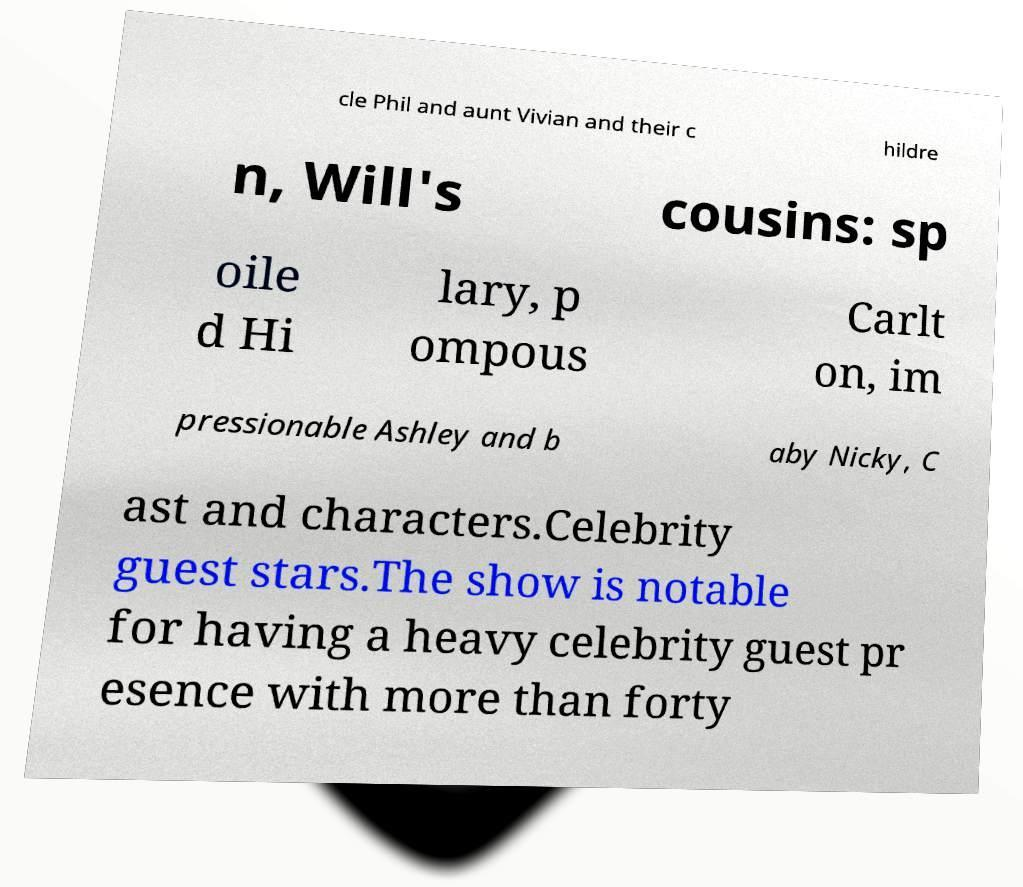I need the written content from this picture converted into text. Can you do that? cle Phil and aunt Vivian and their c hildre n, Will's cousins: sp oile d Hi lary, p ompous Carlt on, im pressionable Ashley and b aby Nicky, C ast and characters.Celebrity guest stars.The show is notable for having a heavy celebrity guest pr esence with more than forty 